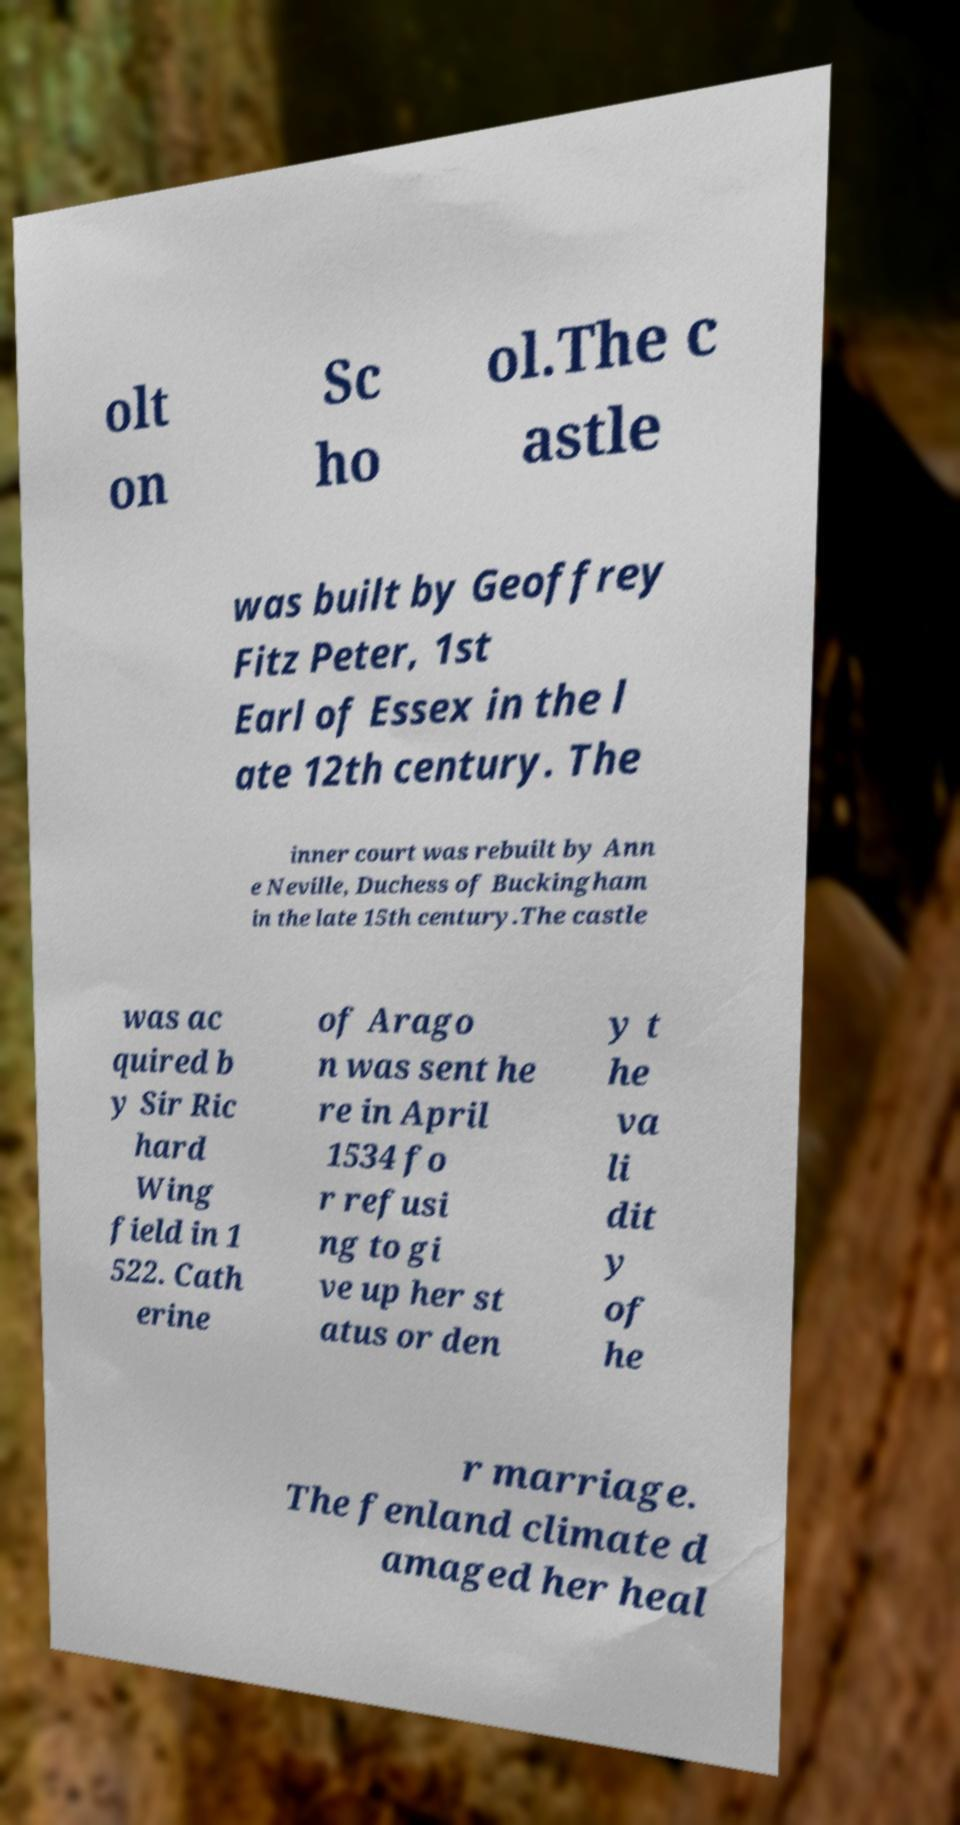I need the written content from this picture converted into text. Can you do that? olt on Sc ho ol.The c astle was built by Geoffrey Fitz Peter, 1st Earl of Essex in the l ate 12th century. The inner court was rebuilt by Ann e Neville, Duchess of Buckingham in the late 15th century.The castle was ac quired b y Sir Ric hard Wing field in 1 522. Cath erine of Arago n was sent he re in April 1534 fo r refusi ng to gi ve up her st atus or den y t he va li dit y of he r marriage. The fenland climate d amaged her heal 